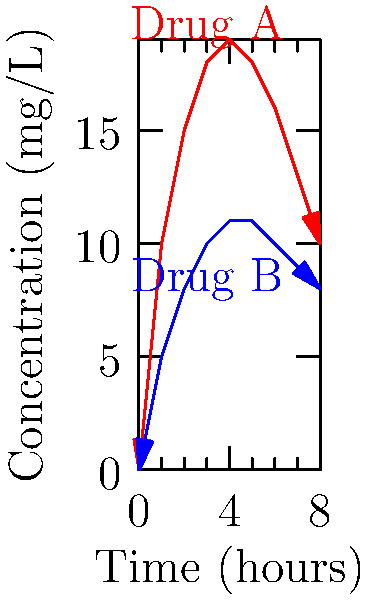As a pharmaceutical manufacturer, you are comparing the concentration-time profiles of two drugs, A and B. Based on the graph, which drug is likely to require more frequent dosing to maintain therapeutic levels? To determine which drug requires more frequent dosing, we need to analyze the concentration-time profiles:

1. Observe the peak concentrations:
   - Drug A reaches a higher peak concentration (about 19 mg/L) at around 4 hours.
   - Drug B reaches a lower peak concentration (about 11 mg/L) at around 4-5 hours.

2. Analyze the rate of concentration decline:
   - Drug A shows a steeper decline after reaching its peak.
   - Drug B shows a more gradual decline after reaching its peak.

3. Compare the concentrations at the end of the time period (8 hours):
   - Drug A's concentration drops to about 10 mg/L.
   - Drug B's concentration remains at about 8 mg/L.

4. Consider the implications for dosing frequency:
   - A faster decline in concentration (as seen with Drug A) typically requires more frequent dosing to maintain therapeutic levels.
   - A more stable concentration over time (as seen with Drug B) usually allows for less frequent dosing.

5. Conclusion:
   Drug A is likely to require more frequent dosing due to its faster decline in concentration over time compared to Drug B.
Answer: Drug A 